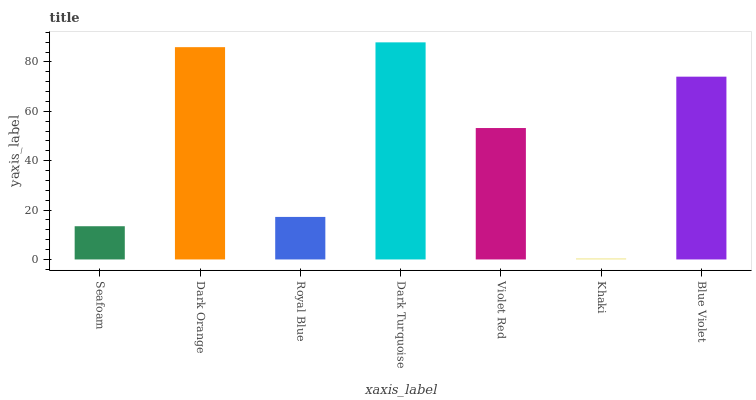Is Khaki the minimum?
Answer yes or no. Yes. Is Dark Turquoise the maximum?
Answer yes or no. Yes. Is Dark Orange the minimum?
Answer yes or no. No. Is Dark Orange the maximum?
Answer yes or no. No. Is Dark Orange greater than Seafoam?
Answer yes or no. Yes. Is Seafoam less than Dark Orange?
Answer yes or no. Yes. Is Seafoam greater than Dark Orange?
Answer yes or no. No. Is Dark Orange less than Seafoam?
Answer yes or no. No. Is Violet Red the high median?
Answer yes or no. Yes. Is Violet Red the low median?
Answer yes or no. Yes. Is Royal Blue the high median?
Answer yes or no. No. Is Dark Turquoise the low median?
Answer yes or no. No. 